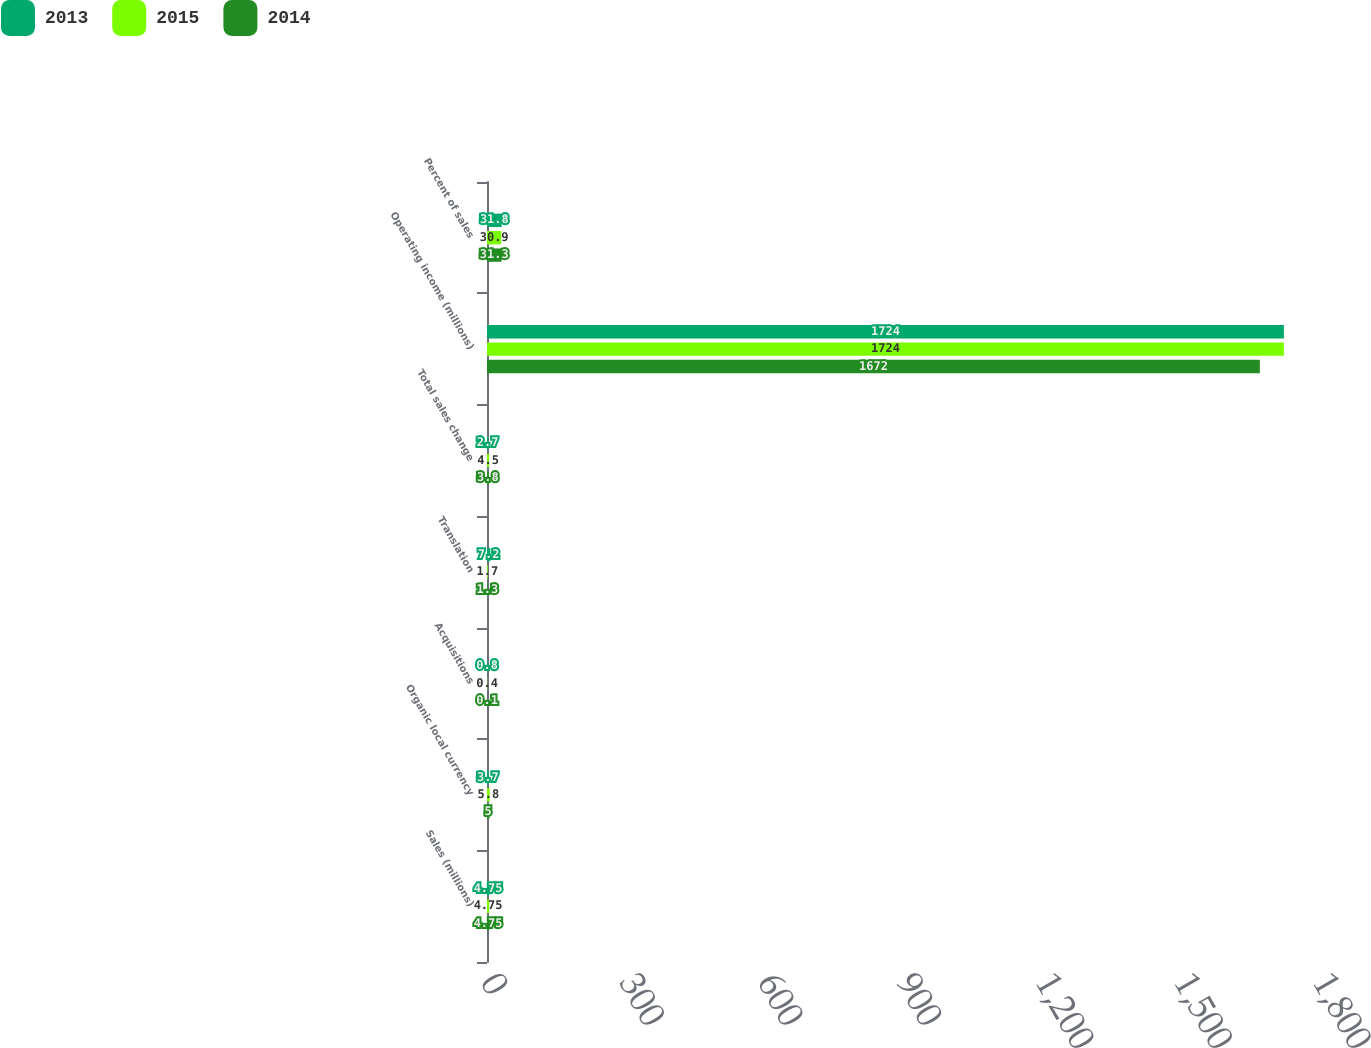<chart> <loc_0><loc_0><loc_500><loc_500><stacked_bar_chart><ecel><fcel>Sales (millions)<fcel>Organic local currency<fcel>Acquisitions<fcel>Translation<fcel>Total sales change<fcel>Operating income (millions)<fcel>Percent of sales<nl><fcel>2013<fcel>4.75<fcel>3.7<fcel>0.8<fcel>7.2<fcel>2.7<fcel>1724<fcel>31.8<nl><fcel>2015<fcel>4.75<fcel>5.8<fcel>0.4<fcel>1.7<fcel>4.5<fcel>1724<fcel>30.9<nl><fcel>2014<fcel>4.75<fcel>5<fcel>0.1<fcel>1.3<fcel>3.8<fcel>1672<fcel>31.3<nl></chart> 